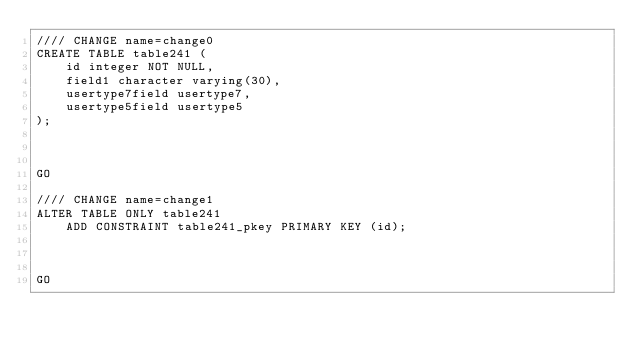Convert code to text. <code><loc_0><loc_0><loc_500><loc_500><_SQL_>//// CHANGE name=change0
CREATE TABLE table241 (
    id integer NOT NULL,
    field1 character varying(30),
    usertype7field usertype7,
    usertype5field usertype5
);



GO

//// CHANGE name=change1
ALTER TABLE ONLY table241
    ADD CONSTRAINT table241_pkey PRIMARY KEY (id);



GO
</code> 